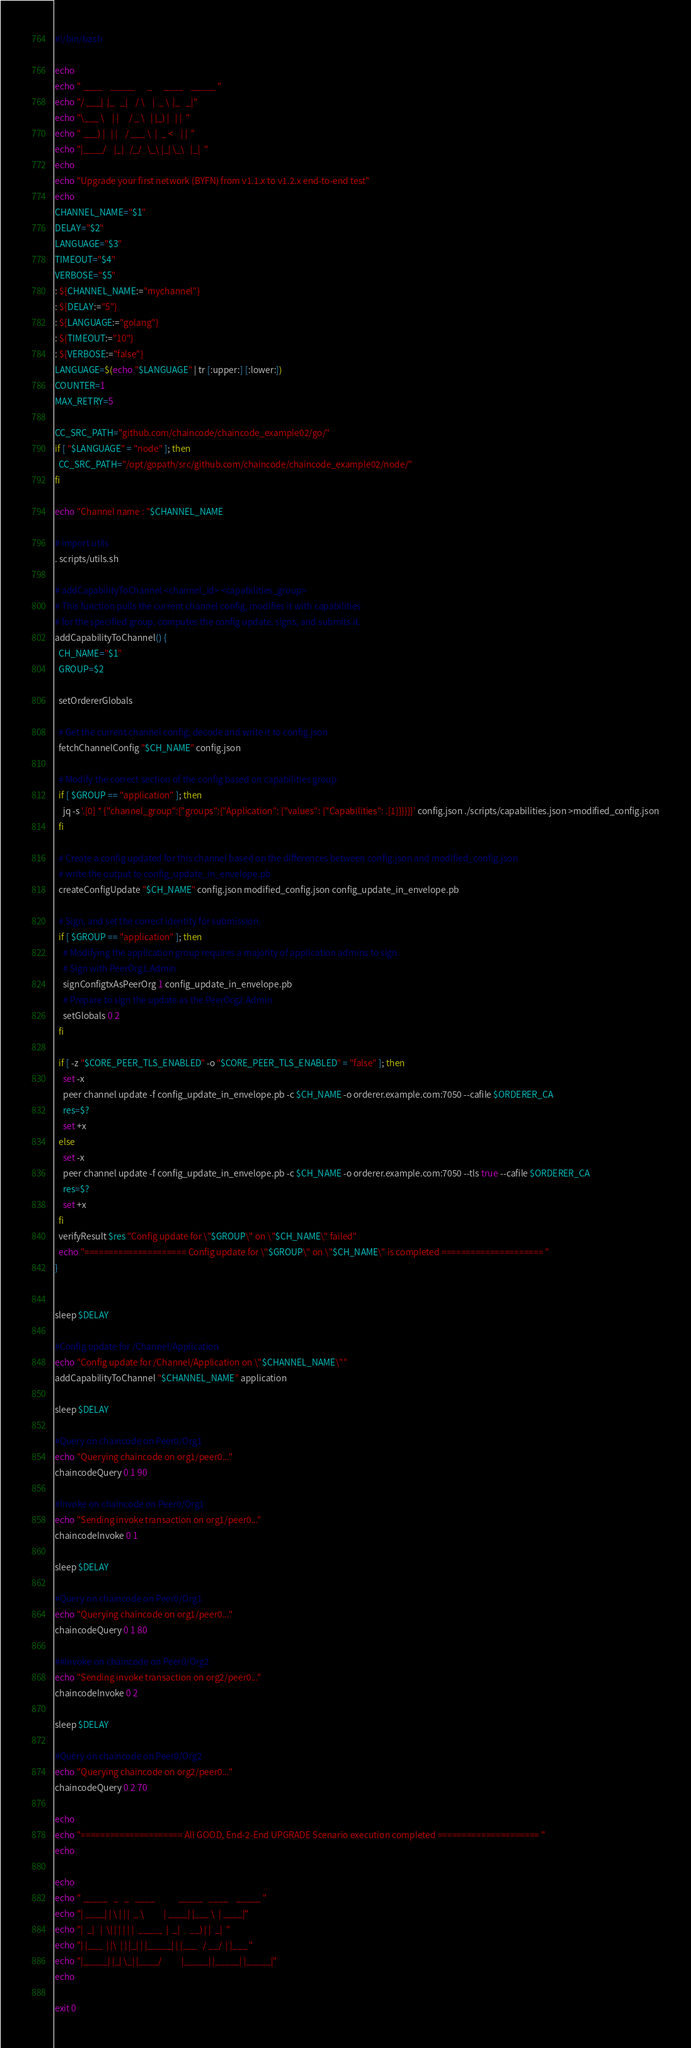<code> <loc_0><loc_0><loc_500><loc_500><_Bash_>#!/bin/bash

echo
echo " ____    _____      _      ____    _____ "
echo "/ ___|  |_   _|    / \    |  _ \  |_   _|"
echo "\___ \    | |     / _ \   | |_) |   | |  "
echo " ___) |   | |    / ___ \  |  _ <    | |  "
echo "|____/    |_|   /_/   \_\ |_| \_\   |_|  "
echo
echo "Upgrade your first network (BYFN) from v1.1.x to v1.2.x end-to-end test"
echo
CHANNEL_NAME="$1"
DELAY="$2"
LANGUAGE="$3"
TIMEOUT="$4"
VERBOSE="$5"
: ${CHANNEL_NAME:="mychannel"}
: ${DELAY:="5"}
: ${LANGUAGE:="golang"}
: ${TIMEOUT:="10"}
: ${VERBOSE:="false"}
LANGUAGE=$(echo "$LANGUAGE" | tr [:upper:] [:lower:])
COUNTER=1
MAX_RETRY=5

CC_SRC_PATH="github.com/chaincode/chaincode_example02/go/"
if [ "$LANGUAGE" = "node" ]; then
  CC_SRC_PATH="/opt/gopath/src/github.com/chaincode/chaincode_example02/node/"
fi

echo "Channel name : "$CHANNEL_NAME

# import utils
. scripts/utils.sh

# addCapabilityToChannel <channel_id> <capabilities_group>
# This function pulls the current channel config, modifies it with capabilities
# for the specified group, computes the config update, signs, and submits it.
addCapabilityToChannel() {
  CH_NAME="$1"
  GROUP=$2

  setOrdererGlobals

  # Get the current channel config, decode and write it to config.json
  fetchChannelConfig "$CH_NAME" config.json

  # Modify the correct section of the config based on capabilities group
  if [ $GROUP == "application" ]; then
    jq -s '.[0] * {"channel_group":{"groups":{"Application": {"values": {"Capabilities": .[1]}}}}}' config.json ./scripts/capabilities.json >modified_config.json
  fi

  # Create a config updated for this channel based on the differences between config.json and modified_config.json
  # write the output to config_update_in_envelope.pb
  createConfigUpdate "$CH_NAME" config.json modified_config.json config_update_in_envelope.pb

  # Sign, and set the correct identity for submission.
  if [ $GROUP == "application" ]; then
    # Modifying the application group requires a majority of application admins to sign.
    # Sign with PeerOrg1.Admin
    signConfigtxAsPeerOrg 1 config_update_in_envelope.pb
    # Prepare to sign the update as the PeerOrg2.Admin
    setGlobals 0 2
  fi

  if [ -z "$CORE_PEER_TLS_ENABLED" -o "$CORE_PEER_TLS_ENABLED" = "false" ]; then
    set -x
    peer channel update -f config_update_in_envelope.pb -c $CH_NAME -o orderer.example.com:7050 --cafile $ORDERER_CA
    res=$?
    set +x
  else
    set -x
    peer channel update -f config_update_in_envelope.pb -c $CH_NAME -o orderer.example.com:7050 --tls true --cafile $ORDERER_CA
    res=$?
    set +x
  fi
  verifyResult $res "Config update for \"$GROUP\" on \"$CH_NAME\" failed"
  echo "===================== Config update for \"$GROUP\" on \"$CH_NAME\" is completed ===================== "
}


sleep $DELAY

#Config update for /Channel/Application
echo "Config update for /Channel/Application on \"$CHANNEL_NAME\""
addCapabilityToChannel "$CHANNEL_NAME" application

sleep $DELAY

#Query on chaincode on Peer0/Org1
echo "Querying chaincode on org1/peer0..."
chaincodeQuery 0 1 90

#Invoke on chaincode on Peer0/Org1
echo "Sending invoke transaction on org1/peer0..."
chaincodeInvoke 0 1

sleep $DELAY

#Query on chaincode on Peer0/Org1
echo "Querying chaincode on org1/peer0..."
chaincodeQuery 0 1 80

##Invoke on chaincode on Peer0/Org2
echo "Sending invoke transaction on org2/peer0..."
chaincodeInvoke 0 2

sleep $DELAY

#Query on chaincode on Peer0/Org2
echo "Querying chaincode on org2/peer0..."
chaincodeQuery 0 2 70

echo
echo "===================== All GOOD, End-2-End UPGRADE Scenario execution completed ===================== "
echo

echo
echo " _____   _   _   ____            _____   ____    _____ "
echo "| ____| | \ | | |  _ \          | ____| |___ \  | ____|"
echo "|  _|   |  \| | | | | |  _____  |  _|     __) | |  _|  "
echo "| |___  | |\  | | |_| | |_____| | |___   / __/  | |___ "
echo "|_____| |_| \_| |____/          |_____| |_____| |_____|"
echo

exit 0
</code> 